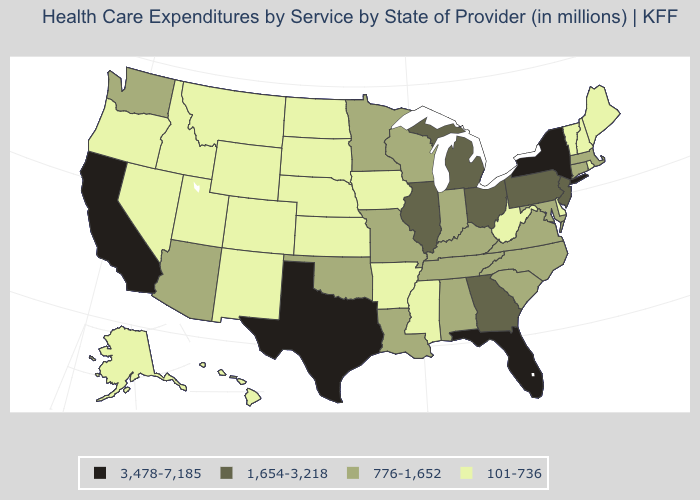Does New York have a higher value than Texas?
Short answer required. No. Name the states that have a value in the range 101-736?
Quick response, please. Alaska, Arkansas, Colorado, Delaware, Hawaii, Idaho, Iowa, Kansas, Maine, Mississippi, Montana, Nebraska, Nevada, New Hampshire, New Mexico, North Dakota, Oregon, Rhode Island, South Dakota, Utah, Vermont, West Virginia, Wyoming. Does Florida have the highest value in the USA?
Concise answer only. Yes. What is the value of New Mexico?
Give a very brief answer. 101-736. Does Iowa have the highest value in the MidWest?
Short answer required. No. Does the map have missing data?
Short answer required. No. Which states have the lowest value in the USA?
Short answer required. Alaska, Arkansas, Colorado, Delaware, Hawaii, Idaho, Iowa, Kansas, Maine, Mississippi, Montana, Nebraska, Nevada, New Hampshire, New Mexico, North Dakota, Oregon, Rhode Island, South Dakota, Utah, Vermont, West Virginia, Wyoming. Does North Carolina have the lowest value in the South?
Give a very brief answer. No. Name the states that have a value in the range 1,654-3,218?
Give a very brief answer. Georgia, Illinois, Michigan, New Jersey, Ohio, Pennsylvania. Does Vermont have the lowest value in the Northeast?
Concise answer only. Yes. What is the value of Alaska?
Keep it brief. 101-736. What is the value of Illinois?
Concise answer only. 1,654-3,218. What is the value of Illinois?
Short answer required. 1,654-3,218. What is the value of Florida?
Concise answer only. 3,478-7,185. Does Arkansas have the same value as Mississippi?
Quick response, please. Yes. 